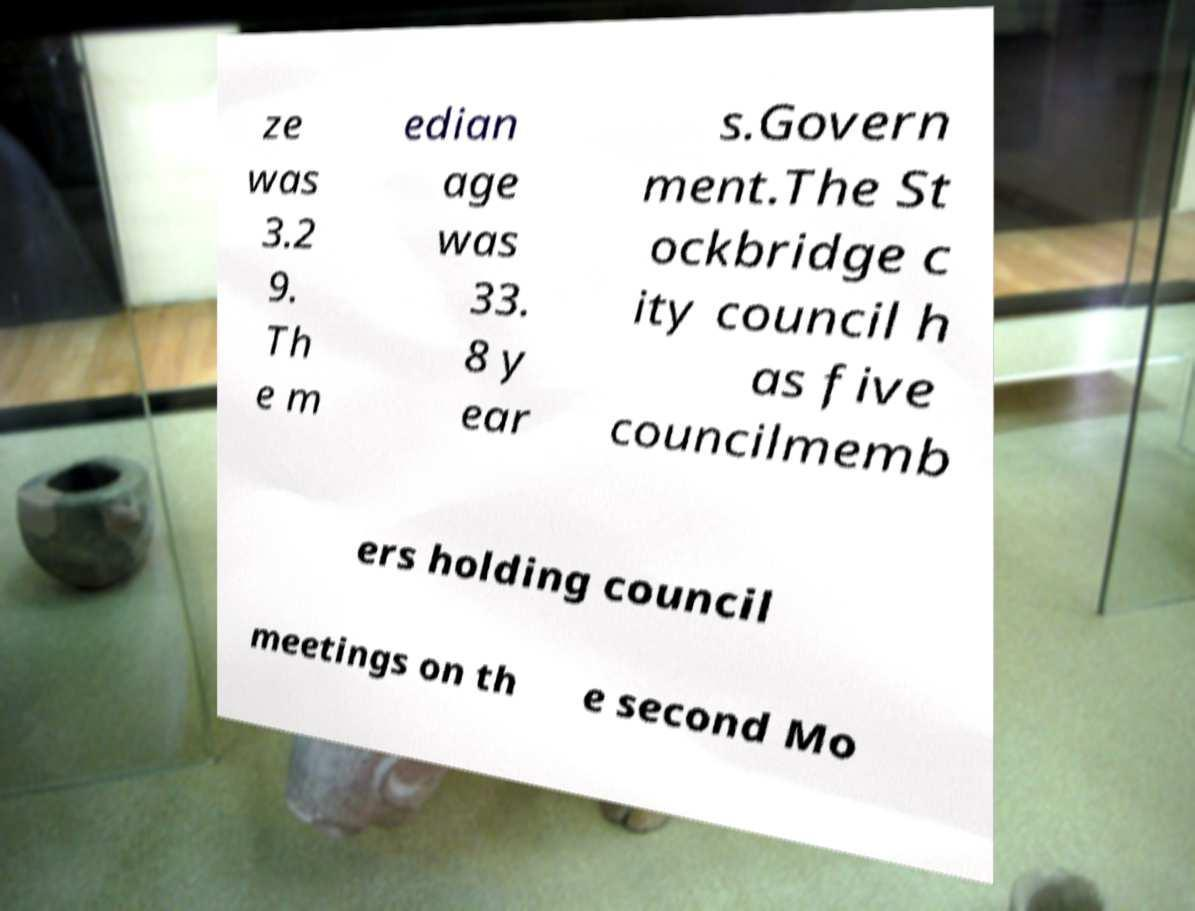Can you accurately transcribe the text from the provided image for me? ze was 3.2 9. Th e m edian age was 33. 8 y ear s.Govern ment.The St ockbridge c ity council h as five councilmemb ers holding council meetings on th e second Mo 